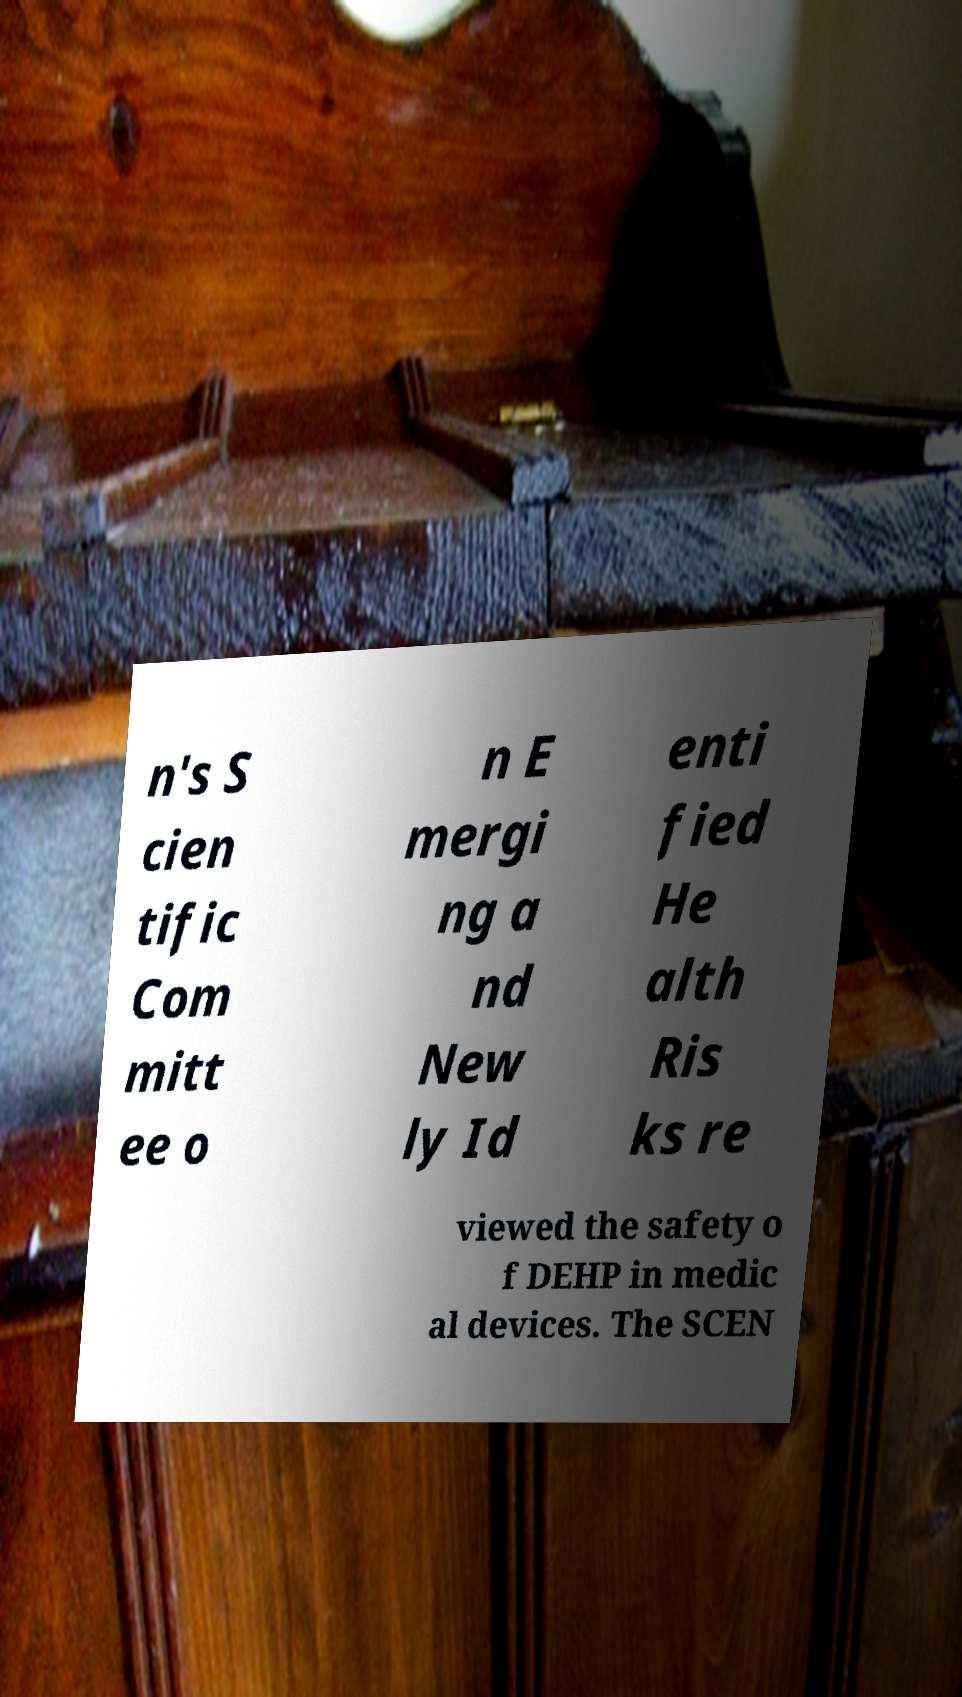Can you read and provide the text displayed in the image?This photo seems to have some interesting text. Can you extract and type it out for me? n's S cien tific Com mitt ee o n E mergi ng a nd New ly Id enti fied He alth Ris ks re viewed the safety o f DEHP in medic al devices. The SCEN 